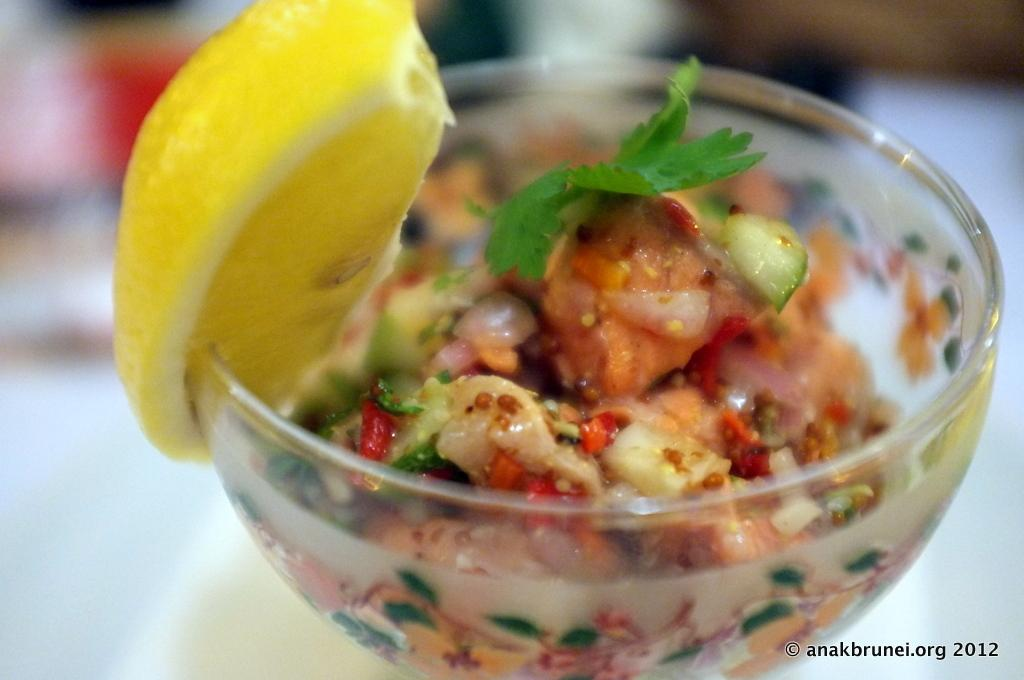What piece of furniture is present in the image? There is a table in the image. What object is placed on the table? There is a glass on the table. What is inside the glass? There is salad in the glass. What is located next to the glass? There is a lemon on the left side of the glass. What type of approval does the society give to the account in the image? There is no mention of society, approval, or account in the image; it only features a table, glass, salad, and lemon. 